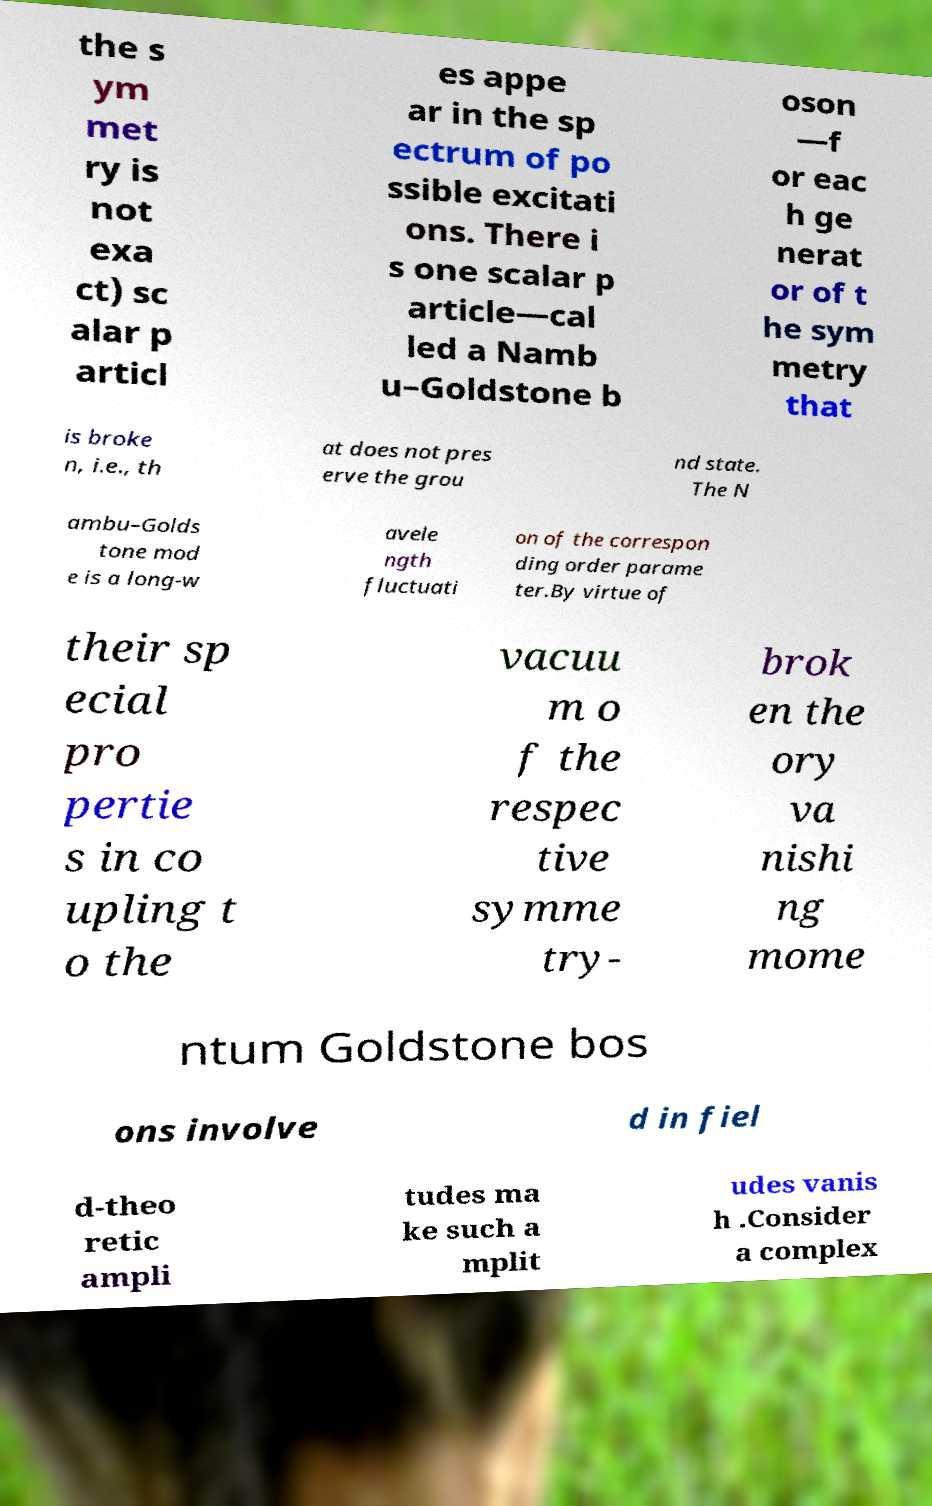Please read and relay the text visible in this image. What does it say? the s ym met ry is not exa ct) sc alar p articl es appe ar in the sp ectrum of po ssible excitati ons. There i s one scalar p article—cal led a Namb u–Goldstone b oson —f or eac h ge nerat or of t he sym metry that is broke n, i.e., th at does not pres erve the grou nd state. The N ambu–Golds tone mod e is a long-w avele ngth fluctuati on of the correspon ding order parame ter.By virtue of their sp ecial pro pertie s in co upling t o the vacuu m o f the respec tive symme try- brok en the ory va nishi ng mome ntum Goldstone bos ons involve d in fiel d-theo retic ampli tudes ma ke such a mplit udes vanis h .Consider a complex 